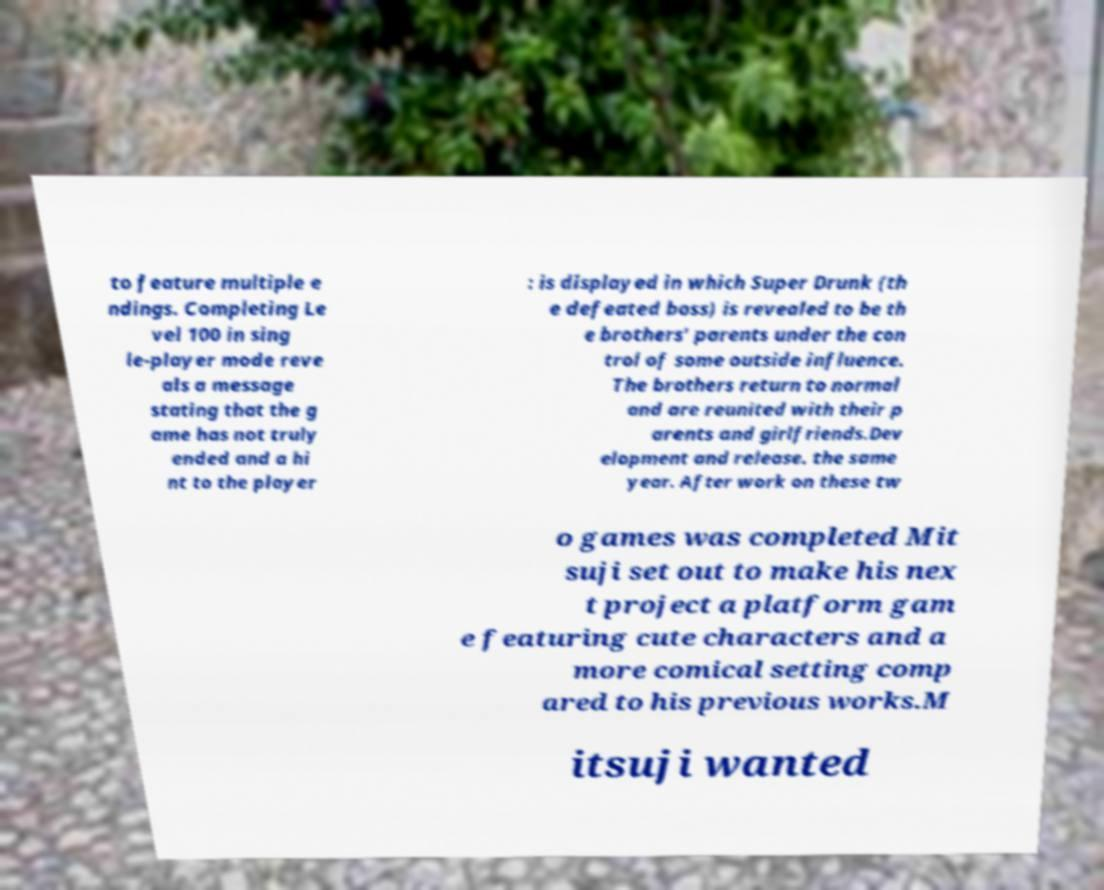Could you assist in decoding the text presented in this image and type it out clearly? to feature multiple e ndings. Completing Le vel 100 in sing le-player mode reve als a message stating that the g ame has not truly ended and a hi nt to the player : is displayed in which Super Drunk (th e defeated boss) is revealed to be th e brothers' parents under the con trol of some outside influence. The brothers return to normal and are reunited with their p arents and girlfriends.Dev elopment and release. the same year. After work on these tw o games was completed Mit suji set out to make his nex t project a platform gam e featuring cute characters and a more comical setting comp ared to his previous works.M itsuji wanted 